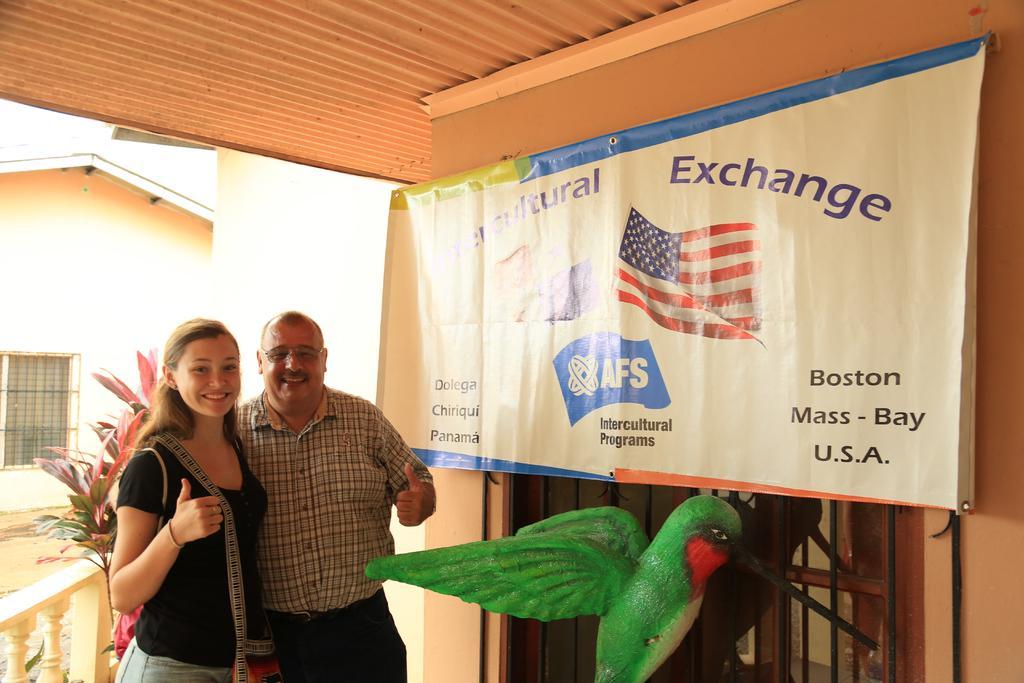How would you summarize this image in a sentence or two? In the foreground of this image, there is a sculpture of bird and behind it there are two persons standing and smiling. In the middle, there is a banner to the wall. On the top, there is a metal sheet. In the background, there is a house and the plant. 